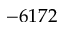Convert formula to latex. <formula><loc_0><loc_0><loc_500><loc_500>- 6 1 7 2</formula> 